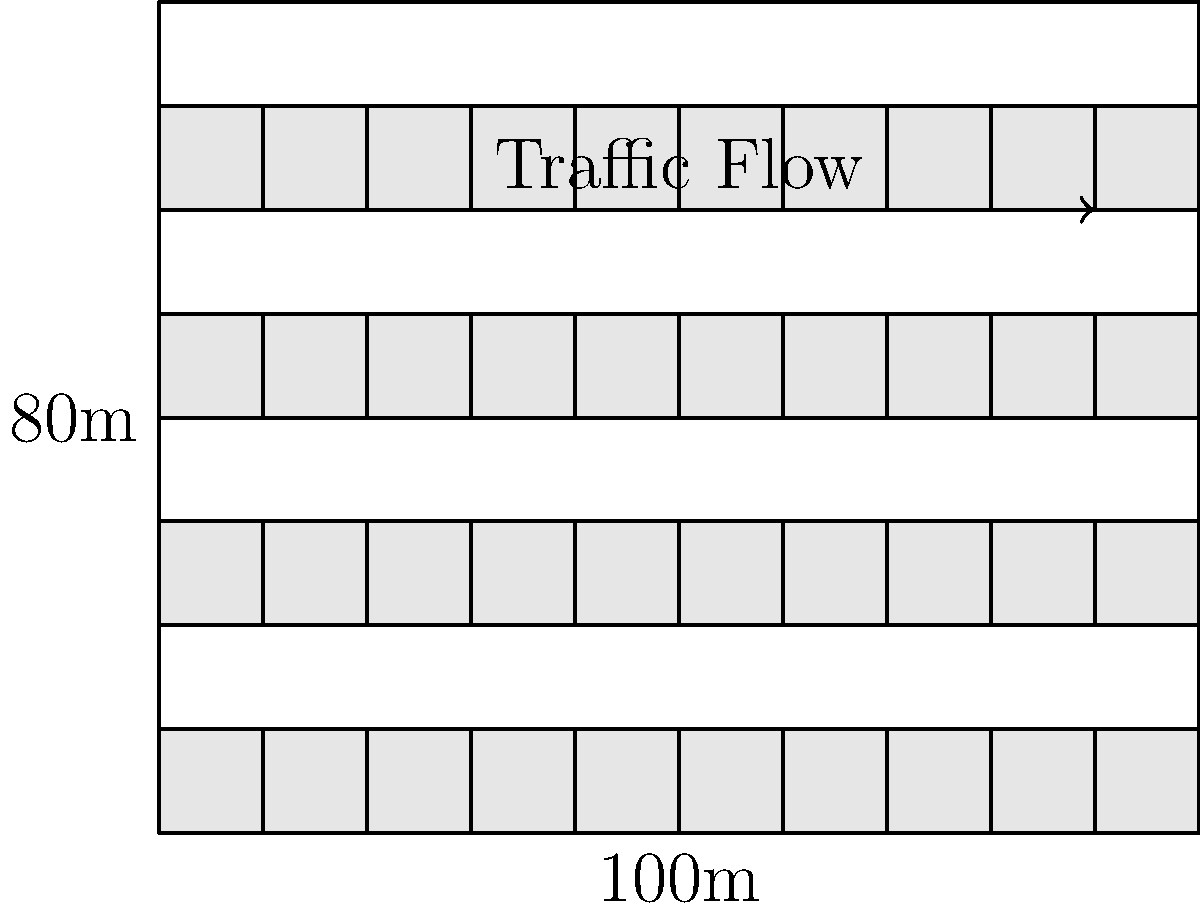Given a rectangular parking lot measuring 100m x 80m, as shown in the diagram, what is the maximum number of standard parking spaces (2.5m x 5m) that can be accommodated while maintaining two 6m-wide driving lanes for traffic flow? Assume all parking spaces are arranged perpendicular to the driving lanes. To solve this problem, let's follow these steps:

1. Calculate the available width for parking spaces:
   Total width = 80m
   Width of two driving lanes = 2 * 6m = 12m
   Available width for parking = 80m - 12m = 68m

2. Determine the number of rows of parking spaces:
   Each parking space is 5m deep
   Number of rows = 68m ÷ 5m = 13.6
   We can fit 13 full rows of parking spaces

3. Calculate the available length for parking spaces:
   Total length = 100m

4. Determine the number of parking spaces per row:
   Each parking space is 2.5m wide
   Spaces per row = 100m ÷ 2.5m = 40

5. Calculate the total number of parking spaces:
   Total spaces = Number of rows * Spaces per row
   Total spaces = 13 * 40 = 520

Therefore, the maximum number of standard parking spaces that can be accommodated in the given area while maintaining two 6m-wide driving lanes is 520.
Answer: 520 parking spaces 